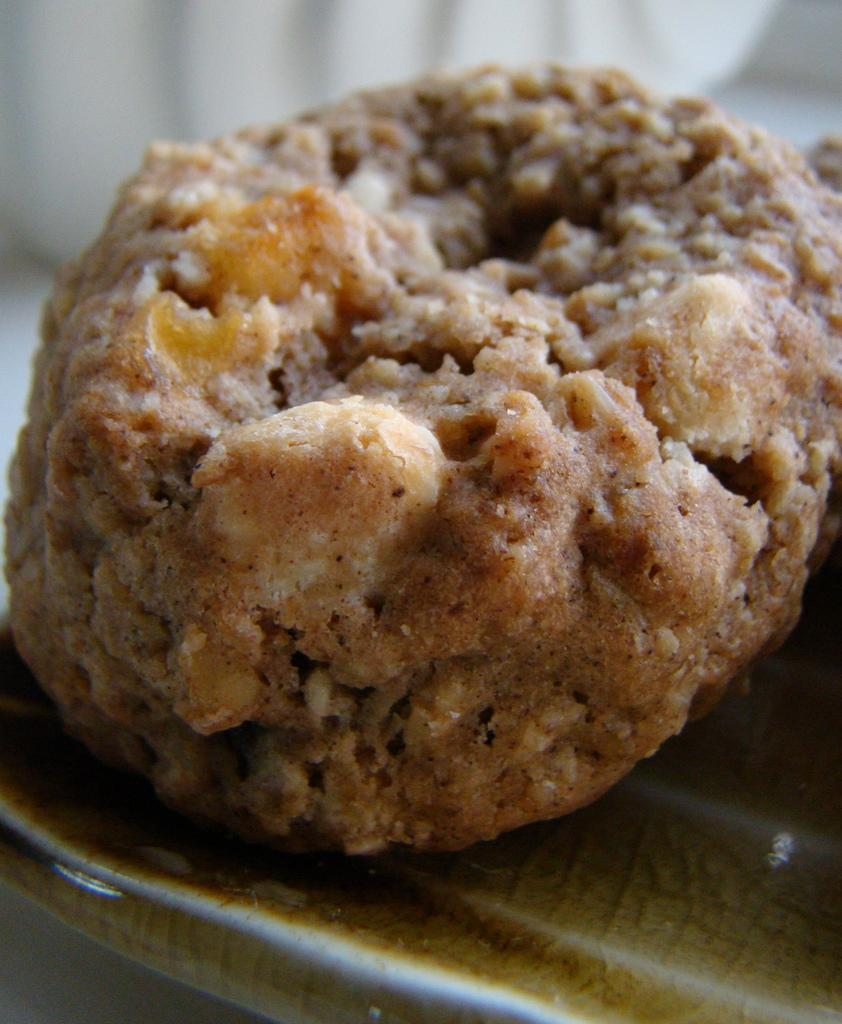What is the main subject of the image? There is a food item on a plate in the image. Can you describe the background of the image? The background of the image is blurred. What type of fruit is being used as a cannon in the image? There is no fruit or cannon present in the image. What flavor of mint can be seen in the image? There is no mint present in the image. 